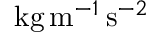Convert formula to latex. <formula><loc_0><loc_0><loc_500><loc_500>k g \, m ^ { - 1 } \, s ^ { - 2 }</formula> 